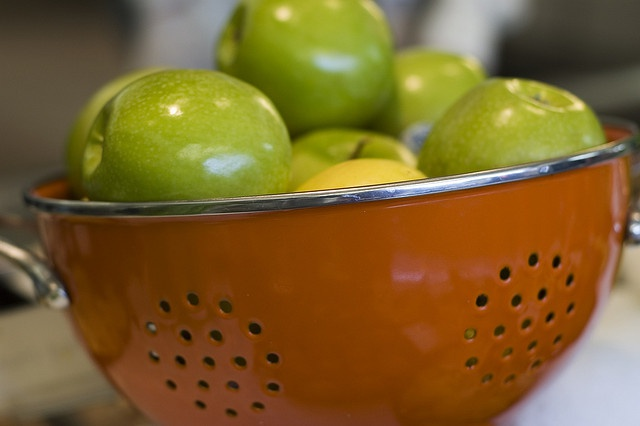Describe the objects in this image and their specific colors. I can see bowl in black, maroon, and brown tones, apple in black and olive tones, and orange in black, gold, and olive tones in this image. 